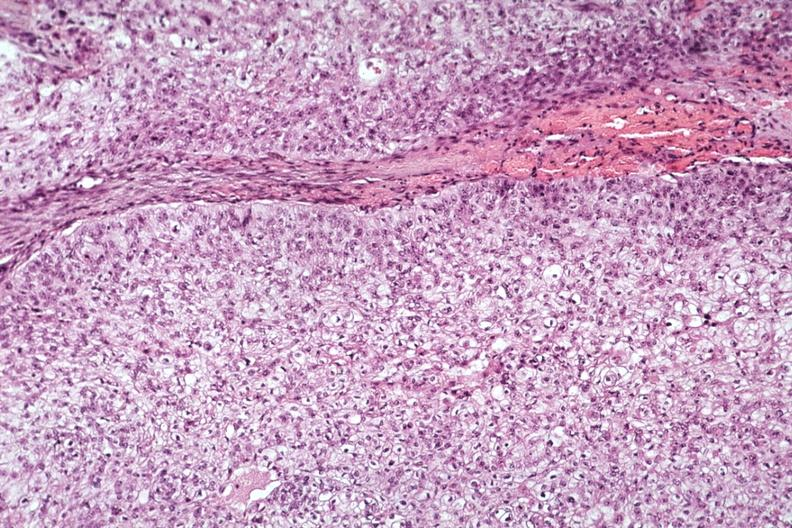s mucoepidermoid carcinoma present?
Answer the question using a single word or phrase. Yes 